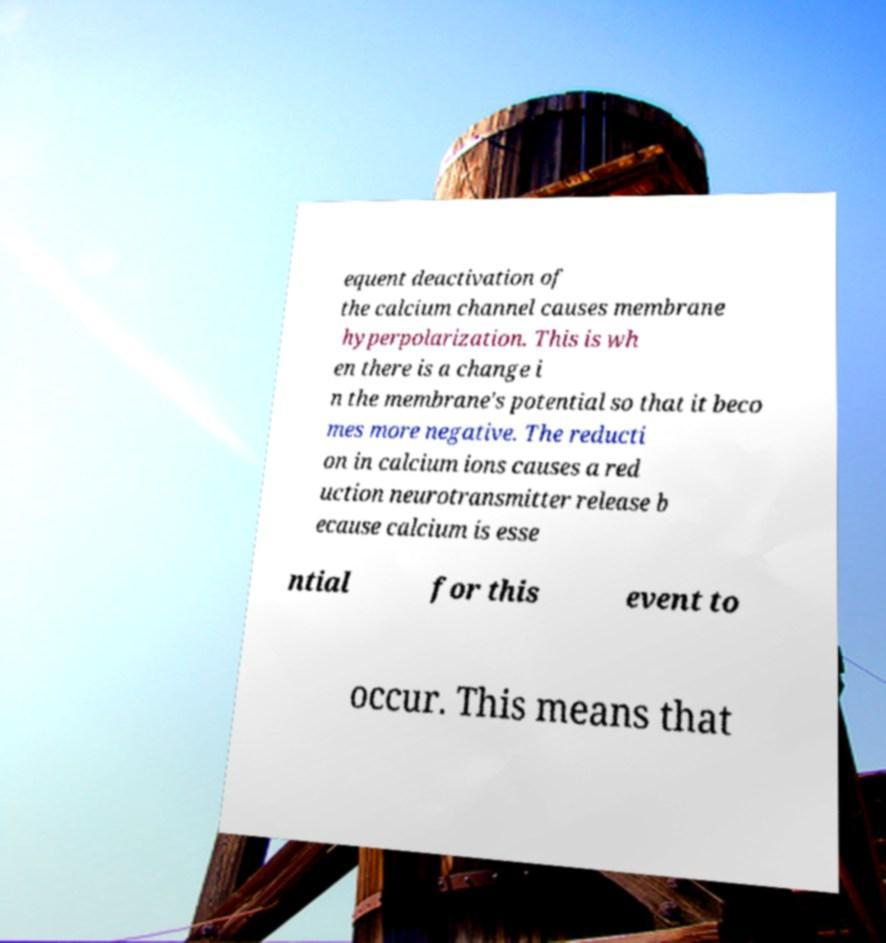There's text embedded in this image that I need extracted. Can you transcribe it verbatim? equent deactivation of the calcium channel causes membrane hyperpolarization. This is wh en there is a change i n the membrane's potential so that it beco mes more negative. The reducti on in calcium ions causes a red uction neurotransmitter release b ecause calcium is esse ntial for this event to occur. This means that 